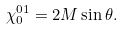Convert formula to latex. <formula><loc_0><loc_0><loc_500><loc_500>\chi ^ { 0 1 } _ { 0 } = 2 M \sin \theta .</formula> 